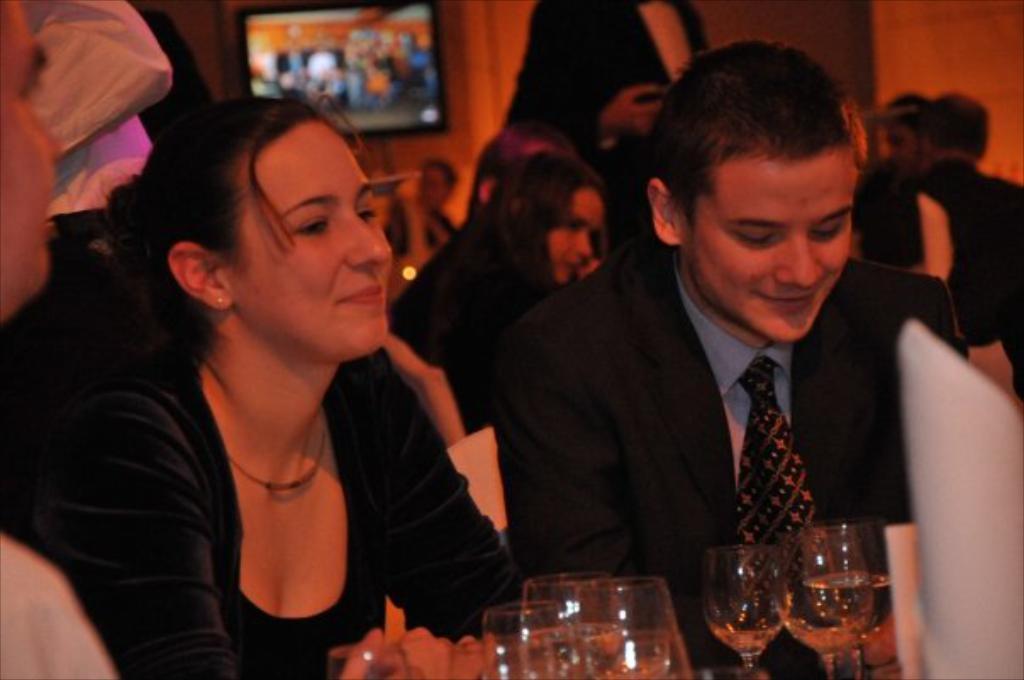Could you give a brief overview of what you see in this image? In this image there are people sitting on chairs, in front of them there is a table, on that table there are glasses, in the background there is a wall for that wall there is a TV. 